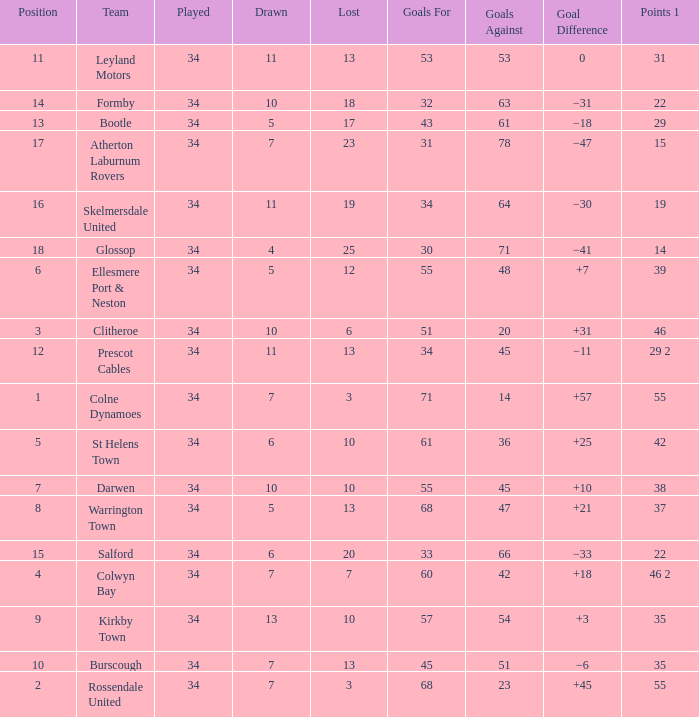How many Drawn have a Lost smaller than 25, and a Goal Difference of +7, and a Played larger than 34? 0.0. 